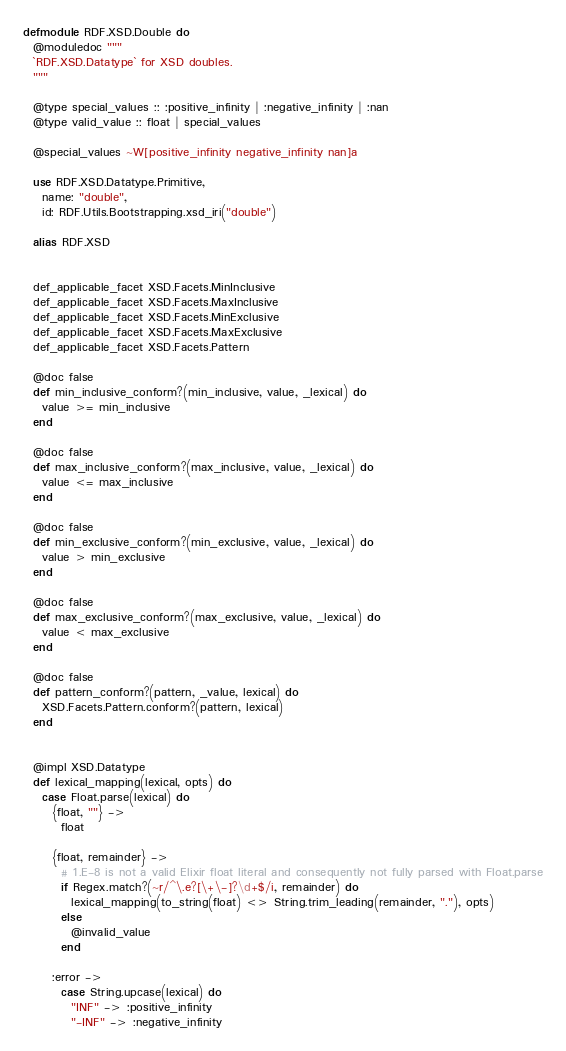Convert code to text. <code><loc_0><loc_0><loc_500><loc_500><_Elixir_>defmodule RDF.XSD.Double do
  @moduledoc """
  `RDF.XSD.Datatype` for XSD doubles.
  """

  @type special_values :: :positive_infinity | :negative_infinity | :nan
  @type valid_value :: float | special_values

  @special_values ~W[positive_infinity negative_infinity nan]a

  use RDF.XSD.Datatype.Primitive,
    name: "double",
    id: RDF.Utils.Bootstrapping.xsd_iri("double")

  alias RDF.XSD


  def_applicable_facet XSD.Facets.MinInclusive
  def_applicable_facet XSD.Facets.MaxInclusive
  def_applicable_facet XSD.Facets.MinExclusive
  def_applicable_facet XSD.Facets.MaxExclusive
  def_applicable_facet XSD.Facets.Pattern

  @doc false
  def min_inclusive_conform?(min_inclusive, value, _lexical) do
    value >= min_inclusive
  end

  @doc false
  def max_inclusive_conform?(max_inclusive, value, _lexical) do
    value <= max_inclusive
  end

  @doc false
  def min_exclusive_conform?(min_exclusive, value, _lexical) do
    value > min_exclusive
  end

  @doc false
  def max_exclusive_conform?(max_exclusive, value, _lexical) do
    value < max_exclusive
  end

  @doc false
  def pattern_conform?(pattern, _value, lexical) do
    XSD.Facets.Pattern.conform?(pattern, lexical)
  end


  @impl XSD.Datatype
  def lexical_mapping(lexical, opts) do
    case Float.parse(lexical) do
      {float, ""} ->
        float

      {float, remainder} ->
        # 1.E-8 is not a valid Elixir float literal and consequently not fully parsed with Float.parse
        if Regex.match?(~r/^\.e?[\+\-]?\d+$/i, remainder) do
          lexical_mapping(to_string(float) <> String.trim_leading(remainder, "."), opts)
        else
          @invalid_value
        end

      :error ->
        case String.upcase(lexical) do
          "INF" -> :positive_infinity
          "-INF" -> :negative_infinity</code> 